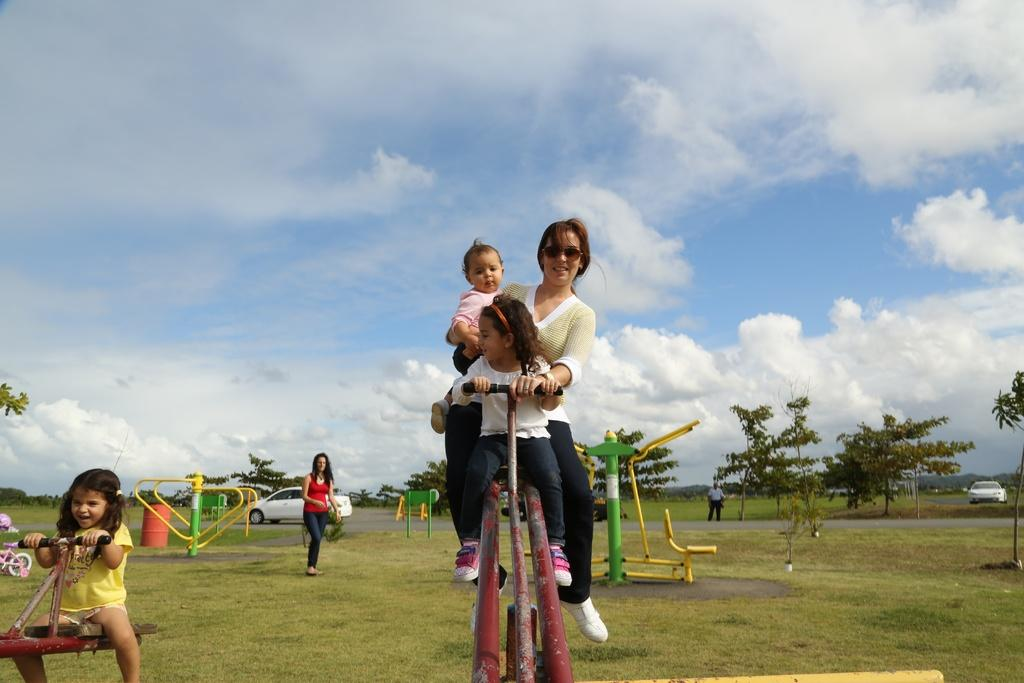How many people are in the group visible in the image? There is a group of people in the image, but the exact number is not specified. What type of objects can be seen in the image? There are metal objects in the image. Where is the image set? The image is set in a park. What can be seen in the background of the image? There are many trees and clouds visible in the background of the image, as well as the sky. What type of wine is being served at the harbor in the image? There is no wine or harbor present in the image; it is set in a park with trees and clouds visible in the background. 